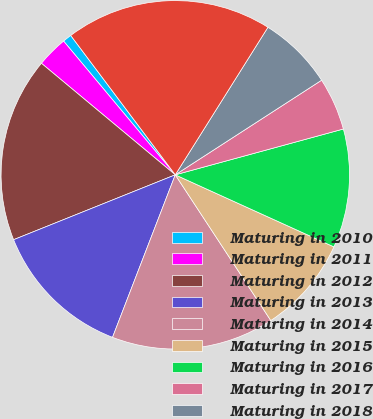<chart> <loc_0><loc_0><loc_500><loc_500><pie_chart><fcel>Maturing in 2010<fcel>Maturing in 2011<fcel>Maturing in 2012<fcel>Maturing in 2013<fcel>Maturing in 2014<fcel>Maturing in 2015<fcel>Maturing in 2016<fcel>Maturing in 2017<fcel>Maturing in 2018<fcel>Maturing in 2019 and beyond<nl><fcel>0.83%<fcel>2.87%<fcel>17.13%<fcel>13.06%<fcel>15.1%<fcel>8.98%<fcel>11.02%<fcel>4.9%<fcel>6.94%<fcel>19.17%<nl></chart> 